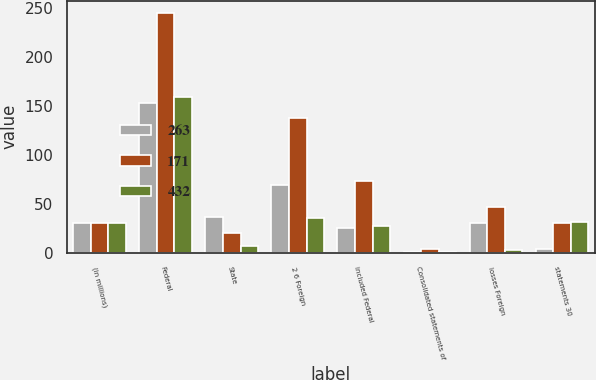Convert chart to OTSL. <chart><loc_0><loc_0><loc_500><loc_500><stacked_bar_chart><ecel><fcel>(in millions)<fcel>Federal<fcel>State<fcel>2 6 Foreign<fcel>included Federal<fcel>Consolidated statements of<fcel>losses Foreign<fcel>statements 30<nl><fcel>263<fcel>30<fcel>153<fcel>37<fcel>69<fcel>25<fcel>1<fcel>30<fcel>4<nl><fcel>171<fcel>30<fcel>245<fcel>20<fcel>137<fcel>73<fcel>4<fcel>47<fcel>30<nl><fcel>432<fcel>30<fcel>159<fcel>7<fcel>36<fcel>27<fcel>1<fcel>3<fcel>31<nl></chart> 